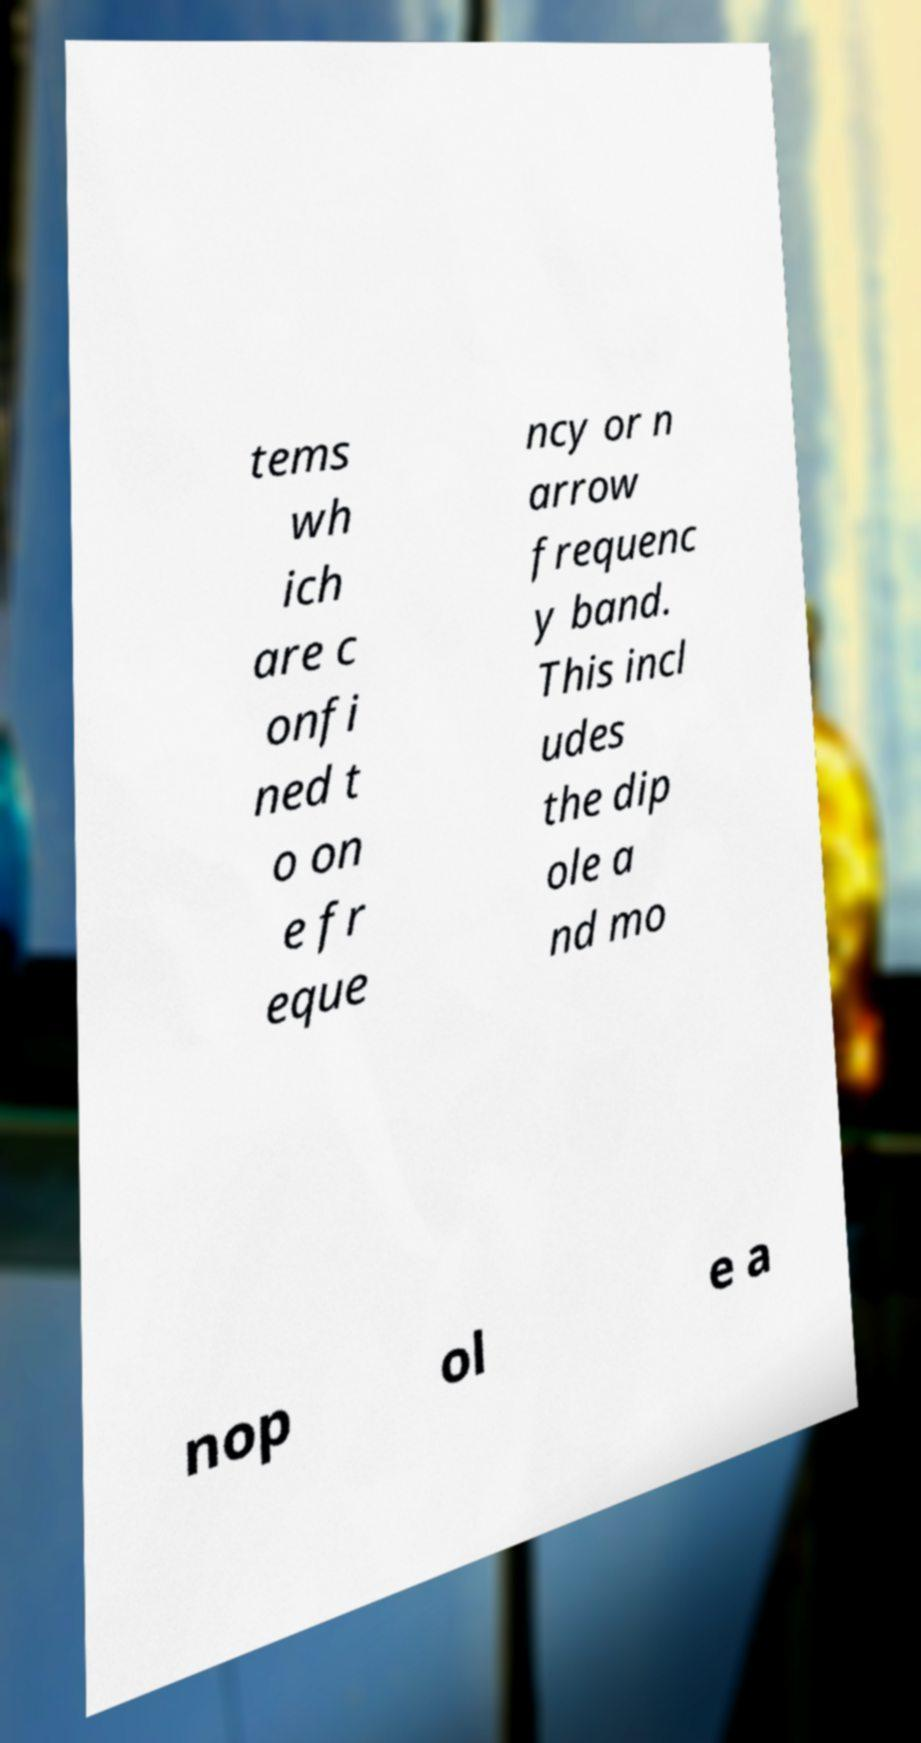There's text embedded in this image that I need extracted. Can you transcribe it verbatim? tems wh ich are c onfi ned t o on e fr eque ncy or n arrow frequenc y band. This incl udes the dip ole a nd mo nop ol e a 